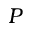<formula> <loc_0><loc_0><loc_500><loc_500>P</formula> 